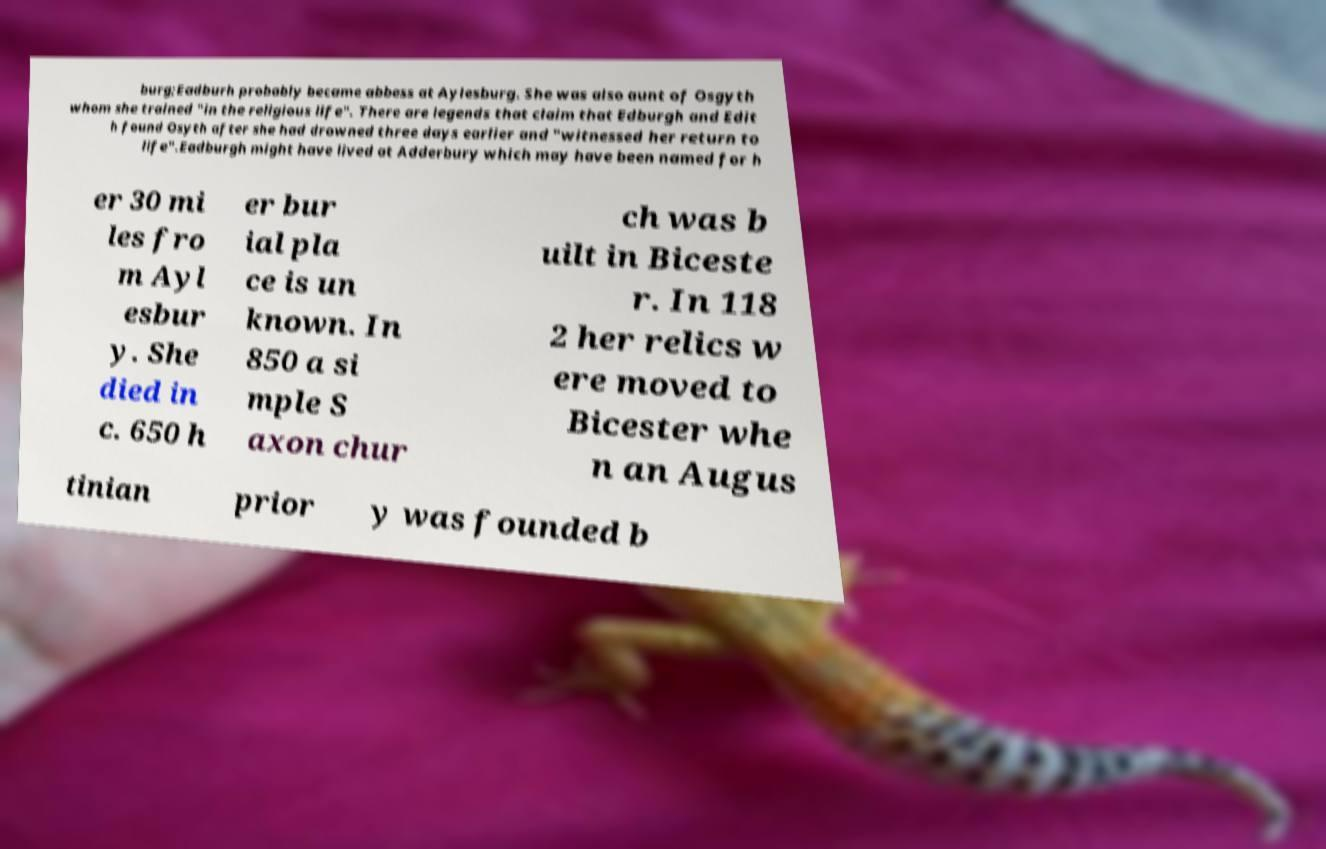Please read and relay the text visible in this image. What does it say? burg;Eadburh probably became abbess at Aylesburg. She was also aunt of Osgyth whom she trained "in the religious life". There are legends that claim that Edburgh and Edit h found Osyth after she had drowned three days earlier and "witnessed her return to life".Eadburgh might have lived at Adderbury which may have been named for h er 30 mi les fro m Ayl esbur y. She died in c. 650 h er bur ial pla ce is un known. In 850 a si mple S axon chur ch was b uilt in Biceste r. In 118 2 her relics w ere moved to Bicester whe n an Augus tinian prior y was founded b 